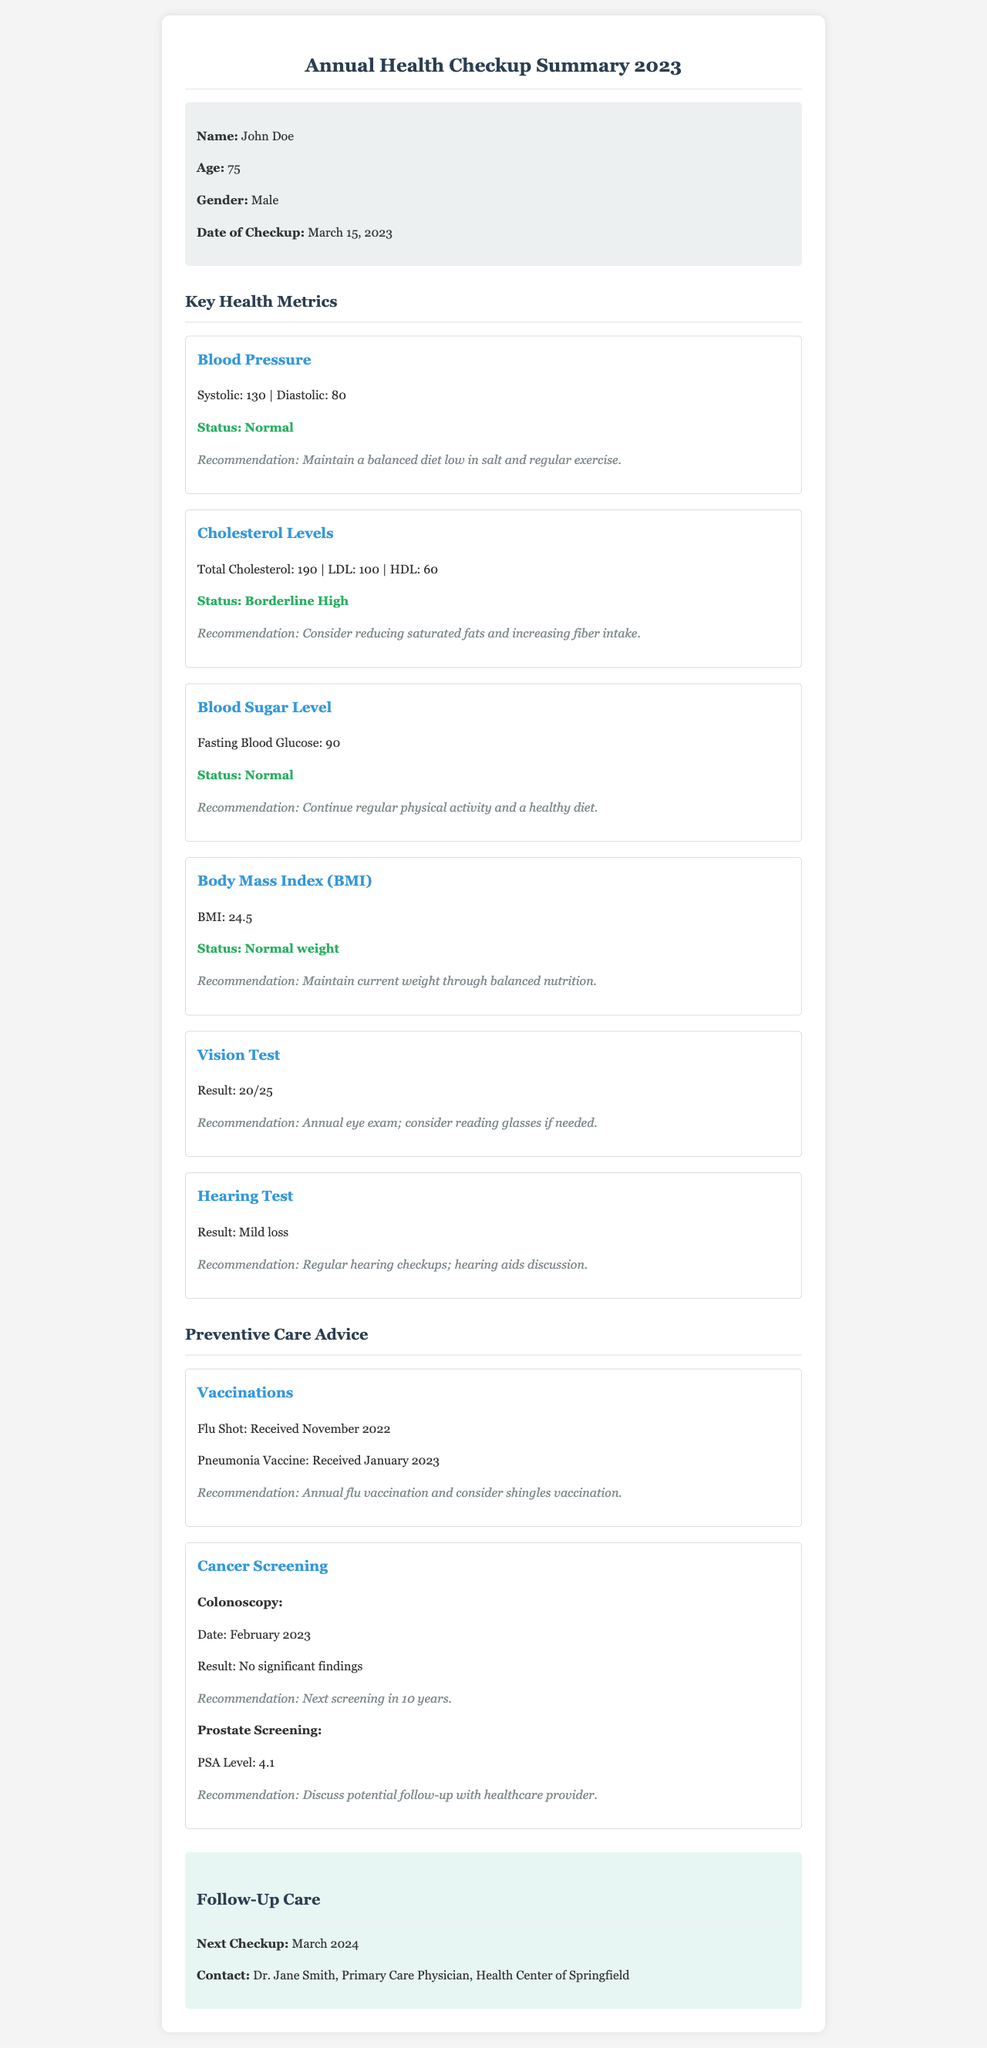What is the name of the patient? The name of the patient is stated at the top of the document.
Answer: John Doe What is John Doe's age? The age of the patient is mentioned in the patient information section.
Answer: 75 What is the systolic blood pressure reading? The systolic blood pressure is provided under the blood pressure metric.
Answer: 130 What is the status of the cholesterol levels? The status of the cholesterol levels is found in the respective section.
Answer: Borderline High When is the next checkup scheduled? The next checkup date is provided in the follow-up care section of the document.
Answer: March 2024 What was the result of the vision test? The result of the vision test is mentioned in the vision test section.
Answer: 20/25 What is the recommendation for the hearing test? The recommendation for the hearing test is provided in its respective section.
Answer: Regular hearing checkups; hearing aids discussion What vaccines did John Doe receive? The vaccinations received are listed in the preventive care advice section.
Answer: Flu Shot and Pneumonia Vaccine How long until the next colonoscopy screening is recommended? The recommendation for colonoscopy screening is specified in the cancer screening section.
Answer: 10 years 